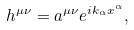Convert formula to latex. <formula><loc_0><loc_0><loc_500><loc_500>h ^ { \mu \nu } = a ^ { \mu \nu } e ^ { i k _ { \alpha } x ^ { \alpha } } ,</formula> 